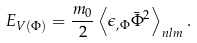<formula> <loc_0><loc_0><loc_500><loc_500>E _ { V ( \Phi ) } = \frac { m _ { 0 } } { 2 } \left \langle \epsilon _ { , \Phi } \bar { \Phi } ^ { 2 } \right \rangle _ { n l m } .</formula> 